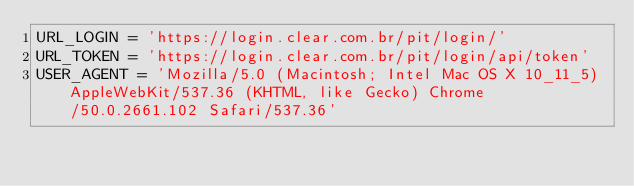Convert code to text. <code><loc_0><loc_0><loc_500><loc_500><_Python_>URL_LOGIN = 'https://login.clear.com.br/pit/login/'
URL_TOKEN = 'https://login.clear.com.br/pit/login/api/token'
USER_AGENT = 'Mozilla/5.0 (Macintosh; Intel Mac OS X 10_11_5) AppleWebKit/537.36 (KHTML, like Gecko) Chrome/50.0.2661.102 Safari/537.36'
</code> 